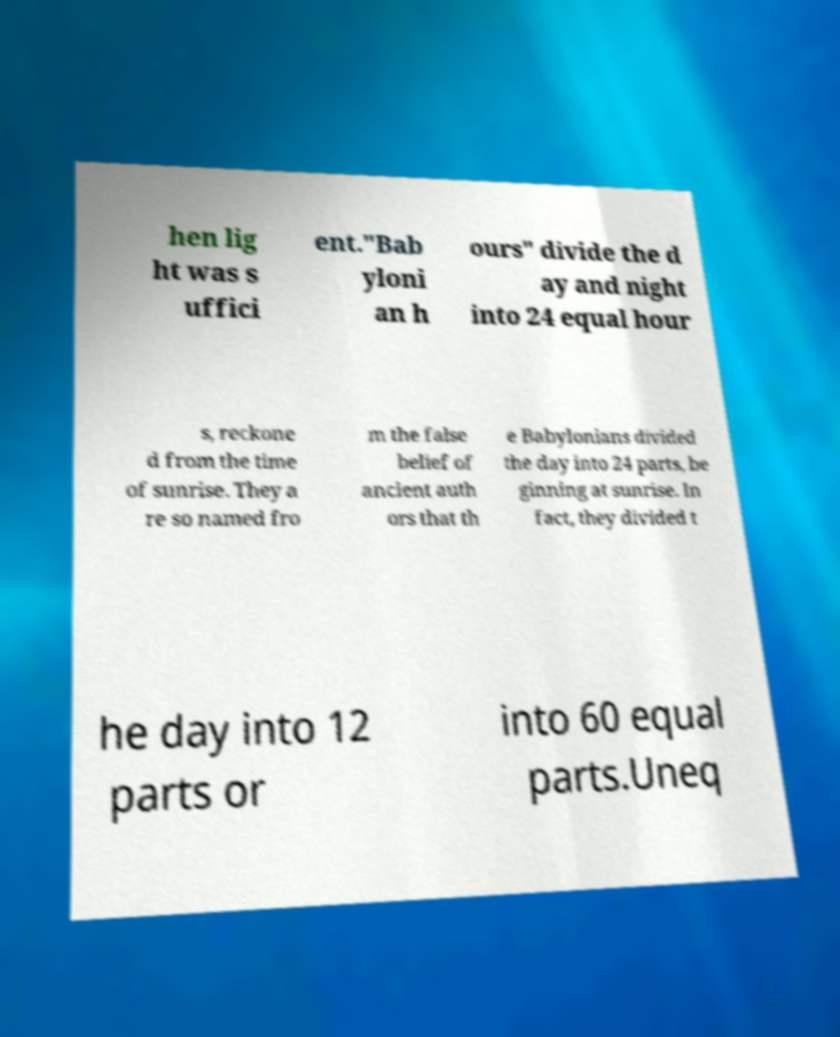For documentation purposes, I need the text within this image transcribed. Could you provide that? hen lig ht was s uffici ent."Bab yloni an h ours" divide the d ay and night into 24 equal hour s, reckone d from the time of sunrise. They a re so named fro m the false belief of ancient auth ors that th e Babylonians divided the day into 24 parts, be ginning at sunrise. In fact, they divided t he day into 12 parts or into 60 equal parts.Uneq 